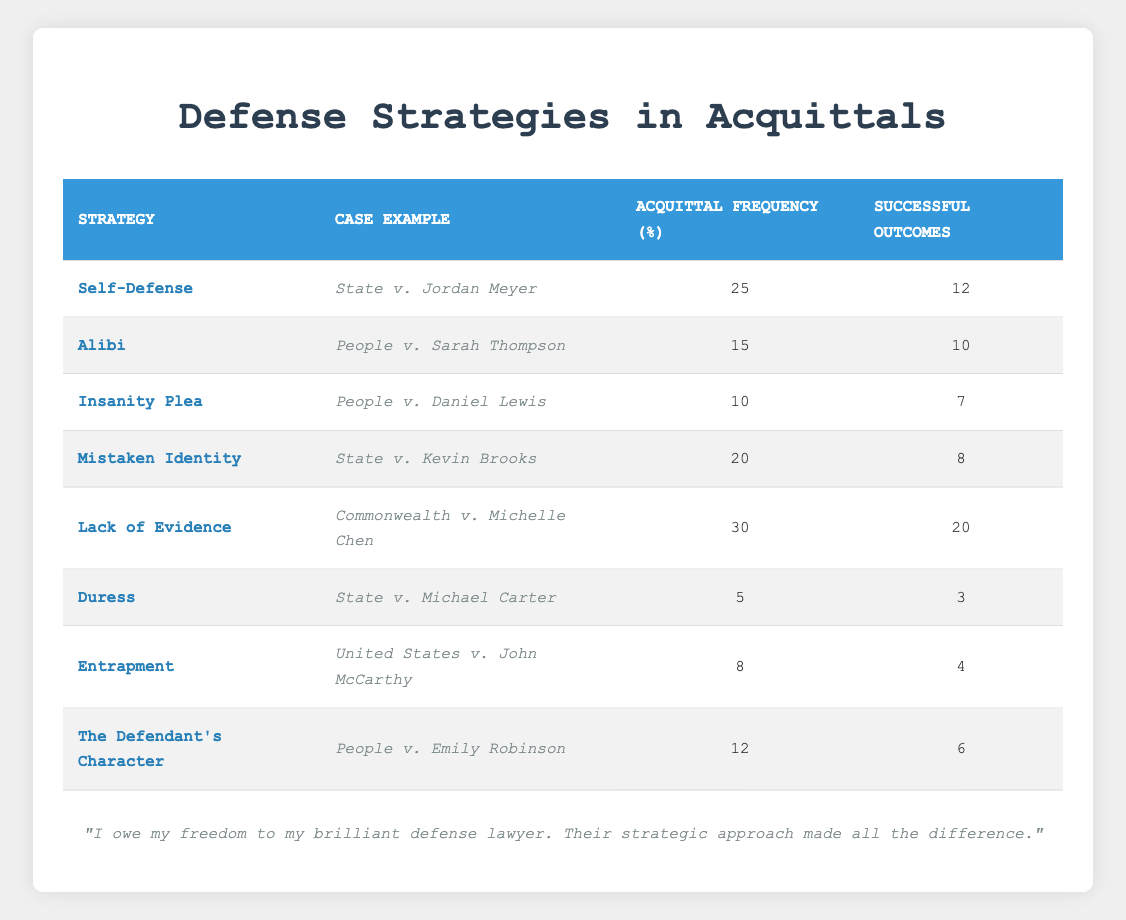What is the defense strategy with the highest acquittal frequency? By examining the "Acquittal Frequency (%)" column in the table, "Lack of Evidence" has the highest value at 30. This can be directly compared to the other strategies listed.
Answer: Lack of Evidence How many successful outcomes were recorded for the "Insanity Plea"? In the "Successful Outcomes" column, the value next to "Insanity Plea" is 7. This value is specifically associated with the case of People v. Daniel Lewis.
Answer: 7 What is the total acquittal frequency of all defense strategies listed? Summing the values in the "Acquittal Frequency (%)" column gives us 25 + 15 + 10 + 20 + 30 + 5 + 8 + 12 = 125. This total reflects all strategies combined.
Answer: 125 True or False: "Entrapment" had more successful outcomes than "Duress". Looking at the "Successful Outcomes" column: "Entrapment" has 4, whereas "Duress" has 3. Since 4 is greater than 3, the statement is True.
Answer: True What strategy had the least number of successful outcomes and what was that number? By reviewing the "Successful Outcomes" column, "Duress" is the strategy with the least successful outcomes listed as 3. This is the lowest value in that column.
Answer: Duress, 3 Which strategy has a successful outcome percentage greater than 40%? To find this, calculate the percentage by dividing successful outcomes by acquittal frequency and multiplying by 100. For all strategies: Lack of Evidence (20/30 * 100 = 66.67%), Self-Defense (12/25 * 100 = 48%), Alibi (10/15 * 100 = 66.67%), and Insanity Plea (7/10 * 100 = 70%). Only "Lack of Evidence" and "Self-Defense" have values greater than 40%.
Answer: Lack of Evidence, Self-Defense What is the average successful outcome rate across all defense strategies? The successful outcomes summed are 12 + 10 + 7 + 8 + 20 + 3 + 4 + 6 = 70. There are 8 strategies, so averaging gives 70 / 8 = 8.75 successful outcomes per strategy.
Answer: 8.75 Which strategy has a success rate (successful outcomes divided by acquittal frequency) closest to 50%? Calculate success rates: Self-Defense (48%), Alibi (66.67%), Insanity Plea (70%), Mistaken Identity (40%), Lack of Evidence (66.67%), Duress (60%), Entrapment (50%), The Defendant’s Character (50%). The close rates are "Entrapment" and "The Defendant’s Character" both at 50%.
Answer: Entrapment, The Defendant's Character What is the case example associated with the "Mistaken Identity" strategy? Referring to the "Case Example" column for the "Mistaken Identity" strategy, it corresponds to the case "State v. Kevin Brooks". This value is explicitly mentioned alongside the strategy in the table.
Answer: State v. Kevin Brooks 